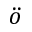<formula> <loc_0><loc_0><loc_500><loc_500>\ddot { o }</formula> 